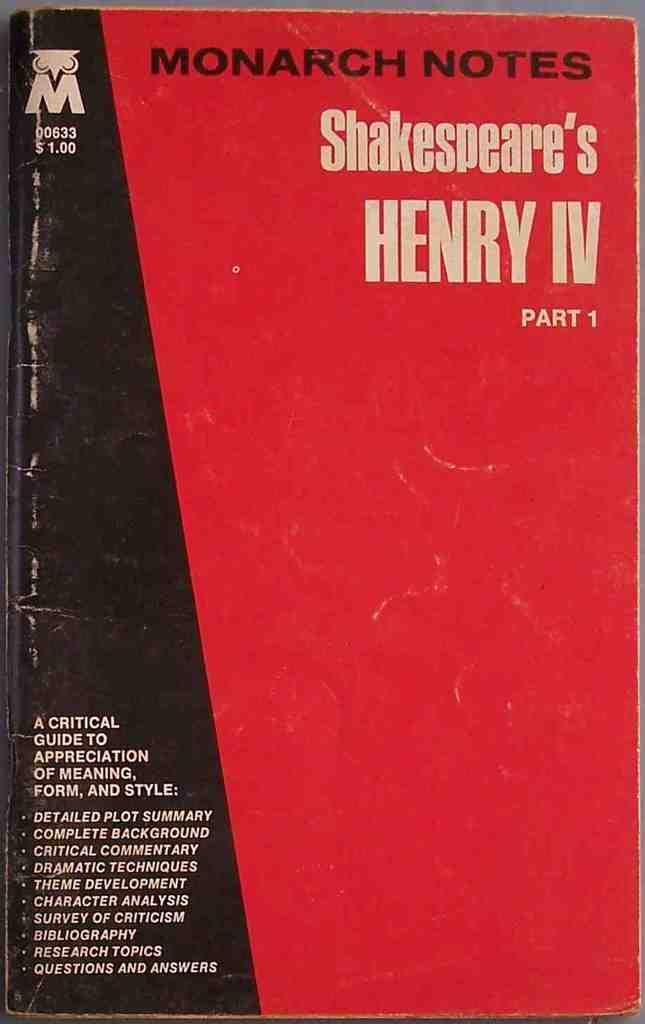Provide a one-sentence caption for the provided image. The image shows a well-worn copy of 'Monarch Notes on Shakespeare's Henry IV Part 1,' featuring a bold red and black design and detailed lists of analyses such as dramatic techniques, theme development, and character analysis, designed to aid students and scholars in their study of the play. 